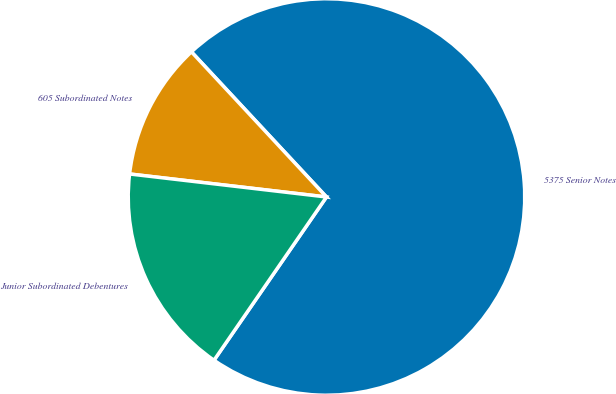Convert chart to OTSL. <chart><loc_0><loc_0><loc_500><loc_500><pie_chart><fcel>5375 Senior Notes<fcel>605 Subordinated Notes<fcel>Junior Subordinated Debentures<nl><fcel>71.53%<fcel>11.22%<fcel>17.25%<nl></chart> 